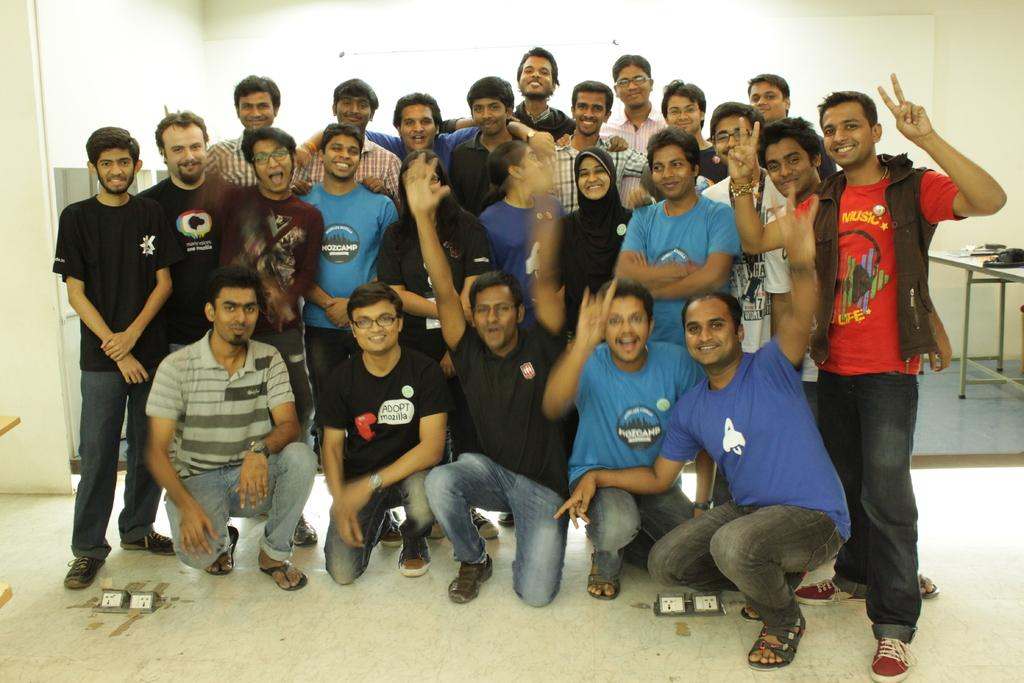What is the main subject of the image? The main subject of the image is a group of people. Where are the people located in the image? The group of people is standing in the center of the image. What else can be seen in the background of the image? There are bags on a bench in the background of the image. What type of rake is being used by the people in the image? There is no rake present in the image; the people are standing without any tools or equipment. 